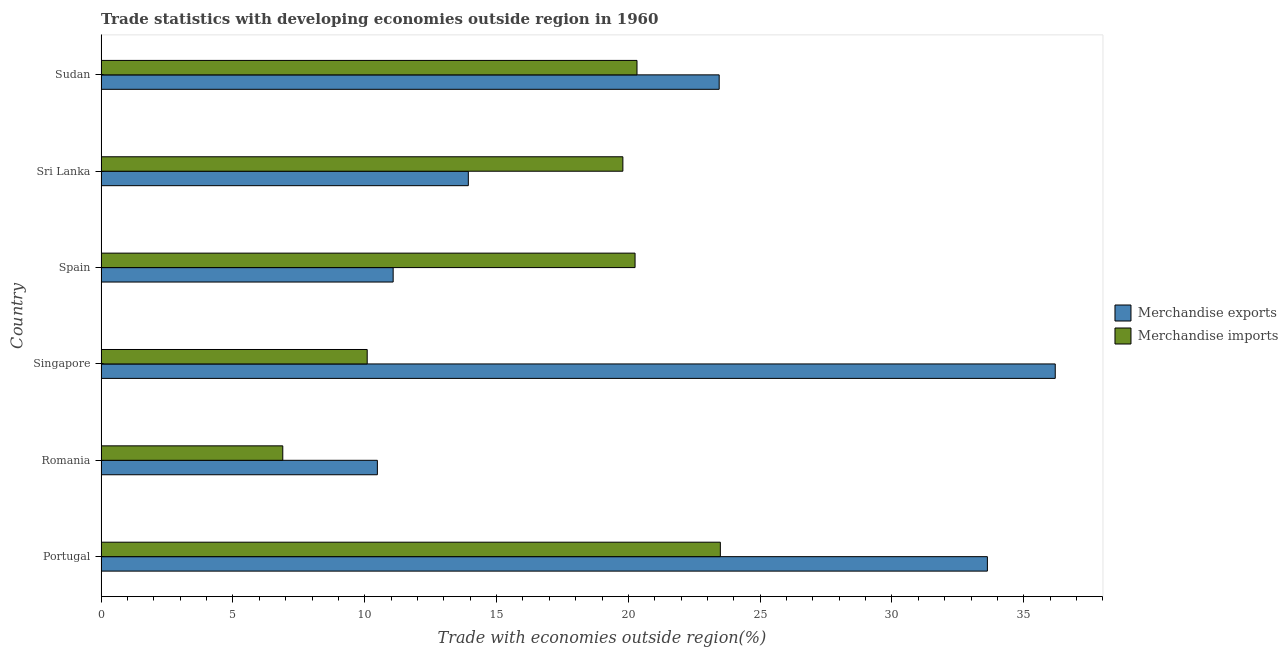How many different coloured bars are there?
Provide a succinct answer. 2. How many bars are there on the 1st tick from the bottom?
Your answer should be very brief. 2. What is the merchandise exports in Spain?
Your answer should be compact. 11.08. Across all countries, what is the maximum merchandise imports?
Offer a very short reply. 23.49. Across all countries, what is the minimum merchandise exports?
Your answer should be very brief. 10.48. In which country was the merchandise imports maximum?
Keep it short and to the point. Portugal. In which country was the merchandise exports minimum?
Make the answer very short. Romania. What is the total merchandise imports in the graph?
Offer a very short reply. 100.85. What is the difference between the merchandise imports in Romania and that in Singapore?
Keep it short and to the point. -3.2. What is the difference between the merchandise exports in Sri Lanka and the merchandise imports in Singapore?
Provide a short and direct response. 3.84. What is the average merchandise exports per country?
Provide a succinct answer. 21.46. What is the difference between the merchandise exports and merchandise imports in Sudan?
Offer a very short reply. 3.12. What is the ratio of the merchandise imports in Portugal to that in Romania?
Your answer should be compact. 3.41. Is the difference between the merchandise exports in Singapore and Sudan greater than the difference between the merchandise imports in Singapore and Sudan?
Your response must be concise. Yes. What is the difference between the highest and the second highest merchandise exports?
Make the answer very short. 2.58. What is the difference between the highest and the lowest merchandise imports?
Ensure brevity in your answer.  16.6. In how many countries, is the merchandise exports greater than the average merchandise exports taken over all countries?
Your answer should be compact. 3. Is the sum of the merchandise exports in Singapore and Sri Lanka greater than the maximum merchandise imports across all countries?
Your response must be concise. Yes. What does the 2nd bar from the bottom in Spain represents?
Provide a short and direct response. Merchandise imports. How many countries are there in the graph?
Ensure brevity in your answer.  6. Does the graph contain grids?
Offer a very short reply. No. How many legend labels are there?
Offer a very short reply. 2. What is the title of the graph?
Give a very brief answer. Trade statistics with developing economies outside region in 1960. Does "Secondary Education" appear as one of the legend labels in the graph?
Offer a very short reply. No. What is the label or title of the X-axis?
Make the answer very short. Trade with economies outside region(%). What is the Trade with economies outside region(%) of Merchandise exports in Portugal?
Your answer should be very brief. 33.62. What is the Trade with economies outside region(%) in Merchandise imports in Portugal?
Keep it short and to the point. 23.49. What is the Trade with economies outside region(%) in Merchandise exports in Romania?
Your answer should be very brief. 10.48. What is the Trade with economies outside region(%) of Merchandise imports in Romania?
Your answer should be very brief. 6.89. What is the Trade with economies outside region(%) in Merchandise exports in Singapore?
Provide a short and direct response. 36.19. What is the Trade with economies outside region(%) of Merchandise imports in Singapore?
Your answer should be very brief. 10.09. What is the Trade with economies outside region(%) of Merchandise exports in Spain?
Ensure brevity in your answer.  11.08. What is the Trade with economies outside region(%) of Merchandise imports in Spain?
Your answer should be very brief. 20.25. What is the Trade with economies outside region(%) of Merchandise exports in Sri Lanka?
Provide a short and direct response. 13.93. What is the Trade with economies outside region(%) of Merchandise imports in Sri Lanka?
Your response must be concise. 19.79. What is the Trade with economies outside region(%) of Merchandise exports in Sudan?
Your response must be concise. 23.45. What is the Trade with economies outside region(%) of Merchandise imports in Sudan?
Offer a very short reply. 20.33. Across all countries, what is the maximum Trade with economies outside region(%) in Merchandise exports?
Your answer should be very brief. 36.19. Across all countries, what is the maximum Trade with economies outside region(%) of Merchandise imports?
Offer a very short reply. 23.49. Across all countries, what is the minimum Trade with economies outside region(%) of Merchandise exports?
Ensure brevity in your answer.  10.48. Across all countries, what is the minimum Trade with economies outside region(%) of Merchandise imports?
Give a very brief answer. 6.89. What is the total Trade with economies outside region(%) in Merchandise exports in the graph?
Provide a succinct answer. 128.74. What is the total Trade with economies outside region(%) in Merchandise imports in the graph?
Ensure brevity in your answer.  100.85. What is the difference between the Trade with economies outside region(%) of Merchandise exports in Portugal and that in Romania?
Your answer should be compact. 23.14. What is the difference between the Trade with economies outside region(%) of Merchandise imports in Portugal and that in Romania?
Your answer should be compact. 16.6. What is the difference between the Trade with economies outside region(%) of Merchandise exports in Portugal and that in Singapore?
Your answer should be very brief. -2.57. What is the difference between the Trade with economies outside region(%) in Merchandise imports in Portugal and that in Singapore?
Your answer should be very brief. 13.4. What is the difference between the Trade with economies outside region(%) of Merchandise exports in Portugal and that in Spain?
Give a very brief answer. 22.54. What is the difference between the Trade with economies outside region(%) of Merchandise imports in Portugal and that in Spain?
Offer a terse response. 3.24. What is the difference between the Trade with economies outside region(%) of Merchandise exports in Portugal and that in Sri Lanka?
Your answer should be very brief. 19.69. What is the difference between the Trade with economies outside region(%) of Merchandise imports in Portugal and that in Sri Lanka?
Keep it short and to the point. 3.7. What is the difference between the Trade with economies outside region(%) in Merchandise exports in Portugal and that in Sudan?
Give a very brief answer. 10.17. What is the difference between the Trade with economies outside region(%) in Merchandise imports in Portugal and that in Sudan?
Keep it short and to the point. 3.16. What is the difference between the Trade with economies outside region(%) in Merchandise exports in Romania and that in Singapore?
Provide a succinct answer. -25.72. What is the difference between the Trade with economies outside region(%) in Merchandise imports in Romania and that in Singapore?
Keep it short and to the point. -3.2. What is the difference between the Trade with economies outside region(%) of Merchandise exports in Romania and that in Spain?
Make the answer very short. -0.6. What is the difference between the Trade with economies outside region(%) in Merchandise imports in Romania and that in Spain?
Your answer should be compact. -13.36. What is the difference between the Trade with economies outside region(%) of Merchandise exports in Romania and that in Sri Lanka?
Give a very brief answer. -3.45. What is the difference between the Trade with economies outside region(%) of Merchandise imports in Romania and that in Sri Lanka?
Ensure brevity in your answer.  -12.9. What is the difference between the Trade with economies outside region(%) in Merchandise exports in Romania and that in Sudan?
Your answer should be very brief. -12.97. What is the difference between the Trade with economies outside region(%) in Merchandise imports in Romania and that in Sudan?
Give a very brief answer. -13.44. What is the difference between the Trade with economies outside region(%) in Merchandise exports in Singapore and that in Spain?
Your answer should be compact. 25.12. What is the difference between the Trade with economies outside region(%) in Merchandise imports in Singapore and that in Spain?
Provide a short and direct response. -10.16. What is the difference between the Trade with economies outside region(%) in Merchandise exports in Singapore and that in Sri Lanka?
Provide a short and direct response. 22.26. What is the difference between the Trade with economies outside region(%) of Merchandise imports in Singapore and that in Sri Lanka?
Your answer should be very brief. -9.7. What is the difference between the Trade with economies outside region(%) of Merchandise exports in Singapore and that in Sudan?
Provide a short and direct response. 12.75. What is the difference between the Trade with economies outside region(%) of Merchandise imports in Singapore and that in Sudan?
Give a very brief answer. -10.23. What is the difference between the Trade with economies outside region(%) of Merchandise exports in Spain and that in Sri Lanka?
Your answer should be compact. -2.85. What is the difference between the Trade with economies outside region(%) of Merchandise imports in Spain and that in Sri Lanka?
Your answer should be compact. 0.46. What is the difference between the Trade with economies outside region(%) in Merchandise exports in Spain and that in Sudan?
Give a very brief answer. -12.37. What is the difference between the Trade with economies outside region(%) in Merchandise imports in Spain and that in Sudan?
Keep it short and to the point. -0.07. What is the difference between the Trade with economies outside region(%) of Merchandise exports in Sri Lanka and that in Sudan?
Offer a very short reply. -9.52. What is the difference between the Trade with economies outside region(%) in Merchandise imports in Sri Lanka and that in Sudan?
Your answer should be compact. -0.54. What is the difference between the Trade with economies outside region(%) of Merchandise exports in Portugal and the Trade with economies outside region(%) of Merchandise imports in Romania?
Provide a short and direct response. 26.73. What is the difference between the Trade with economies outside region(%) of Merchandise exports in Portugal and the Trade with economies outside region(%) of Merchandise imports in Singapore?
Offer a terse response. 23.53. What is the difference between the Trade with economies outside region(%) of Merchandise exports in Portugal and the Trade with economies outside region(%) of Merchandise imports in Spain?
Your answer should be very brief. 13.37. What is the difference between the Trade with economies outside region(%) in Merchandise exports in Portugal and the Trade with economies outside region(%) in Merchandise imports in Sri Lanka?
Provide a short and direct response. 13.83. What is the difference between the Trade with economies outside region(%) in Merchandise exports in Portugal and the Trade with economies outside region(%) in Merchandise imports in Sudan?
Give a very brief answer. 13.29. What is the difference between the Trade with economies outside region(%) in Merchandise exports in Romania and the Trade with economies outside region(%) in Merchandise imports in Singapore?
Your response must be concise. 0.39. What is the difference between the Trade with economies outside region(%) in Merchandise exports in Romania and the Trade with economies outside region(%) in Merchandise imports in Spain?
Your response must be concise. -9.78. What is the difference between the Trade with economies outside region(%) in Merchandise exports in Romania and the Trade with economies outside region(%) in Merchandise imports in Sri Lanka?
Offer a very short reply. -9.31. What is the difference between the Trade with economies outside region(%) of Merchandise exports in Romania and the Trade with economies outside region(%) of Merchandise imports in Sudan?
Ensure brevity in your answer.  -9.85. What is the difference between the Trade with economies outside region(%) in Merchandise exports in Singapore and the Trade with economies outside region(%) in Merchandise imports in Spain?
Give a very brief answer. 15.94. What is the difference between the Trade with economies outside region(%) in Merchandise exports in Singapore and the Trade with economies outside region(%) in Merchandise imports in Sri Lanka?
Give a very brief answer. 16.4. What is the difference between the Trade with economies outside region(%) of Merchandise exports in Singapore and the Trade with economies outside region(%) of Merchandise imports in Sudan?
Ensure brevity in your answer.  15.87. What is the difference between the Trade with economies outside region(%) of Merchandise exports in Spain and the Trade with economies outside region(%) of Merchandise imports in Sri Lanka?
Offer a terse response. -8.71. What is the difference between the Trade with economies outside region(%) of Merchandise exports in Spain and the Trade with economies outside region(%) of Merchandise imports in Sudan?
Offer a very short reply. -9.25. What is the difference between the Trade with economies outside region(%) of Merchandise exports in Sri Lanka and the Trade with economies outside region(%) of Merchandise imports in Sudan?
Your response must be concise. -6.4. What is the average Trade with economies outside region(%) of Merchandise exports per country?
Make the answer very short. 21.46. What is the average Trade with economies outside region(%) of Merchandise imports per country?
Your response must be concise. 16.81. What is the difference between the Trade with economies outside region(%) of Merchandise exports and Trade with economies outside region(%) of Merchandise imports in Portugal?
Offer a very short reply. 10.13. What is the difference between the Trade with economies outside region(%) of Merchandise exports and Trade with economies outside region(%) of Merchandise imports in Romania?
Keep it short and to the point. 3.59. What is the difference between the Trade with economies outside region(%) of Merchandise exports and Trade with economies outside region(%) of Merchandise imports in Singapore?
Make the answer very short. 26.1. What is the difference between the Trade with economies outside region(%) in Merchandise exports and Trade with economies outside region(%) in Merchandise imports in Spain?
Your answer should be compact. -9.18. What is the difference between the Trade with economies outside region(%) in Merchandise exports and Trade with economies outside region(%) in Merchandise imports in Sri Lanka?
Your response must be concise. -5.86. What is the difference between the Trade with economies outside region(%) of Merchandise exports and Trade with economies outside region(%) of Merchandise imports in Sudan?
Your response must be concise. 3.12. What is the ratio of the Trade with economies outside region(%) in Merchandise exports in Portugal to that in Romania?
Provide a short and direct response. 3.21. What is the ratio of the Trade with economies outside region(%) in Merchandise imports in Portugal to that in Romania?
Your answer should be compact. 3.41. What is the ratio of the Trade with economies outside region(%) of Merchandise exports in Portugal to that in Singapore?
Offer a terse response. 0.93. What is the ratio of the Trade with economies outside region(%) of Merchandise imports in Portugal to that in Singapore?
Offer a very short reply. 2.33. What is the ratio of the Trade with economies outside region(%) in Merchandise exports in Portugal to that in Spain?
Offer a very short reply. 3.03. What is the ratio of the Trade with economies outside region(%) in Merchandise imports in Portugal to that in Spain?
Provide a short and direct response. 1.16. What is the ratio of the Trade with economies outside region(%) in Merchandise exports in Portugal to that in Sri Lanka?
Provide a succinct answer. 2.41. What is the ratio of the Trade with economies outside region(%) in Merchandise imports in Portugal to that in Sri Lanka?
Provide a succinct answer. 1.19. What is the ratio of the Trade with economies outside region(%) of Merchandise exports in Portugal to that in Sudan?
Keep it short and to the point. 1.43. What is the ratio of the Trade with economies outside region(%) in Merchandise imports in Portugal to that in Sudan?
Your response must be concise. 1.16. What is the ratio of the Trade with economies outside region(%) of Merchandise exports in Romania to that in Singapore?
Provide a short and direct response. 0.29. What is the ratio of the Trade with economies outside region(%) of Merchandise imports in Romania to that in Singapore?
Give a very brief answer. 0.68. What is the ratio of the Trade with economies outside region(%) of Merchandise exports in Romania to that in Spain?
Provide a short and direct response. 0.95. What is the ratio of the Trade with economies outside region(%) in Merchandise imports in Romania to that in Spain?
Ensure brevity in your answer.  0.34. What is the ratio of the Trade with economies outside region(%) of Merchandise exports in Romania to that in Sri Lanka?
Ensure brevity in your answer.  0.75. What is the ratio of the Trade with economies outside region(%) of Merchandise imports in Romania to that in Sri Lanka?
Make the answer very short. 0.35. What is the ratio of the Trade with economies outside region(%) in Merchandise exports in Romania to that in Sudan?
Ensure brevity in your answer.  0.45. What is the ratio of the Trade with economies outside region(%) in Merchandise imports in Romania to that in Sudan?
Your response must be concise. 0.34. What is the ratio of the Trade with economies outside region(%) of Merchandise exports in Singapore to that in Spain?
Your response must be concise. 3.27. What is the ratio of the Trade with economies outside region(%) in Merchandise imports in Singapore to that in Spain?
Your answer should be compact. 0.5. What is the ratio of the Trade with economies outside region(%) in Merchandise exports in Singapore to that in Sri Lanka?
Your answer should be compact. 2.6. What is the ratio of the Trade with economies outside region(%) of Merchandise imports in Singapore to that in Sri Lanka?
Offer a terse response. 0.51. What is the ratio of the Trade with economies outside region(%) of Merchandise exports in Singapore to that in Sudan?
Give a very brief answer. 1.54. What is the ratio of the Trade with economies outside region(%) of Merchandise imports in Singapore to that in Sudan?
Make the answer very short. 0.5. What is the ratio of the Trade with economies outside region(%) in Merchandise exports in Spain to that in Sri Lanka?
Your response must be concise. 0.8. What is the ratio of the Trade with economies outside region(%) of Merchandise imports in Spain to that in Sri Lanka?
Provide a succinct answer. 1.02. What is the ratio of the Trade with economies outside region(%) of Merchandise exports in Spain to that in Sudan?
Offer a very short reply. 0.47. What is the ratio of the Trade with economies outside region(%) of Merchandise exports in Sri Lanka to that in Sudan?
Offer a terse response. 0.59. What is the ratio of the Trade with economies outside region(%) in Merchandise imports in Sri Lanka to that in Sudan?
Your response must be concise. 0.97. What is the difference between the highest and the second highest Trade with economies outside region(%) of Merchandise exports?
Provide a succinct answer. 2.57. What is the difference between the highest and the second highest Trade with economies outside region(%) of Merchandise imports?
Keep it short and to the point. 3.16. What is the difference between the highest and the lowest Trade with economies outside region(%) in Merchandise exports?
Make the answer very short. 25.72. What is the difference between the highest and the lowest Trade with economies outside region(%) in Merchandise imports?
Give a very brief answer. 16.6. 